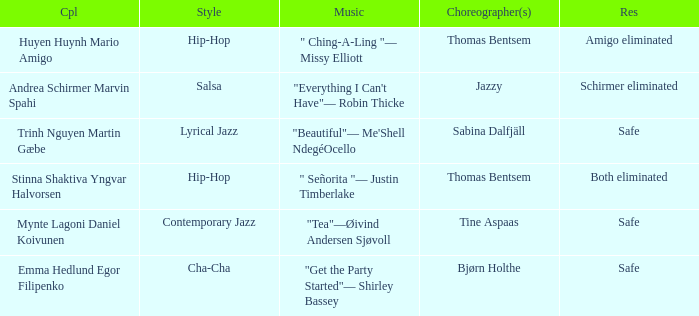What is the musical composition for choreographer sabina dalfjäll? "Beautiful"— Me'Shell NdegéOcello. 